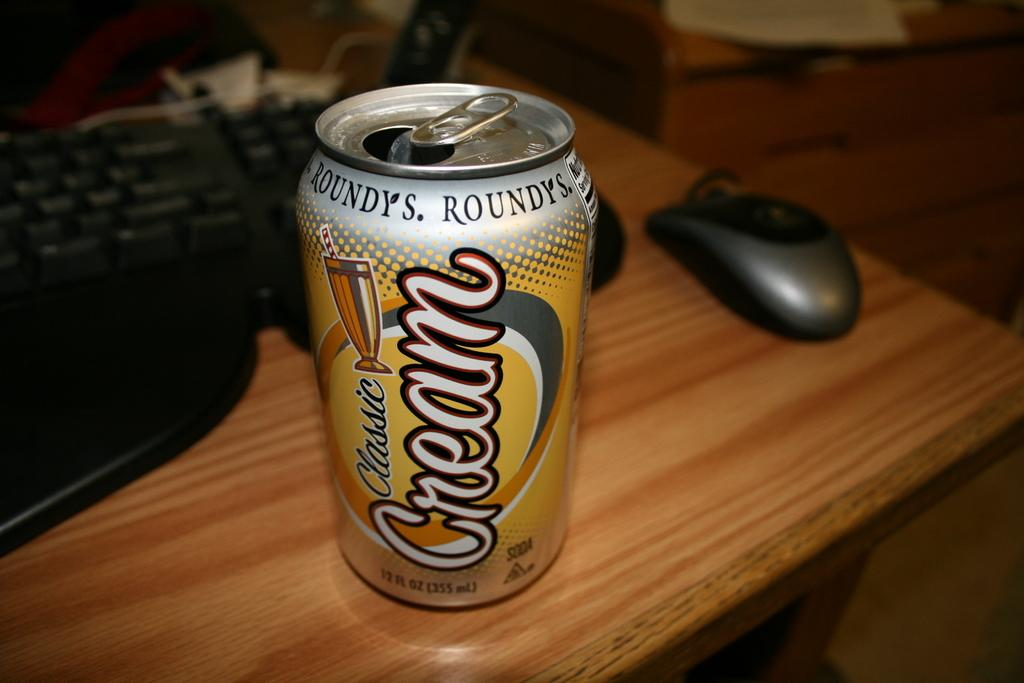<image>
Give a short and clear explanation of the subsequent image. A can of Classic Cream Roundy's soda on a wood table. 